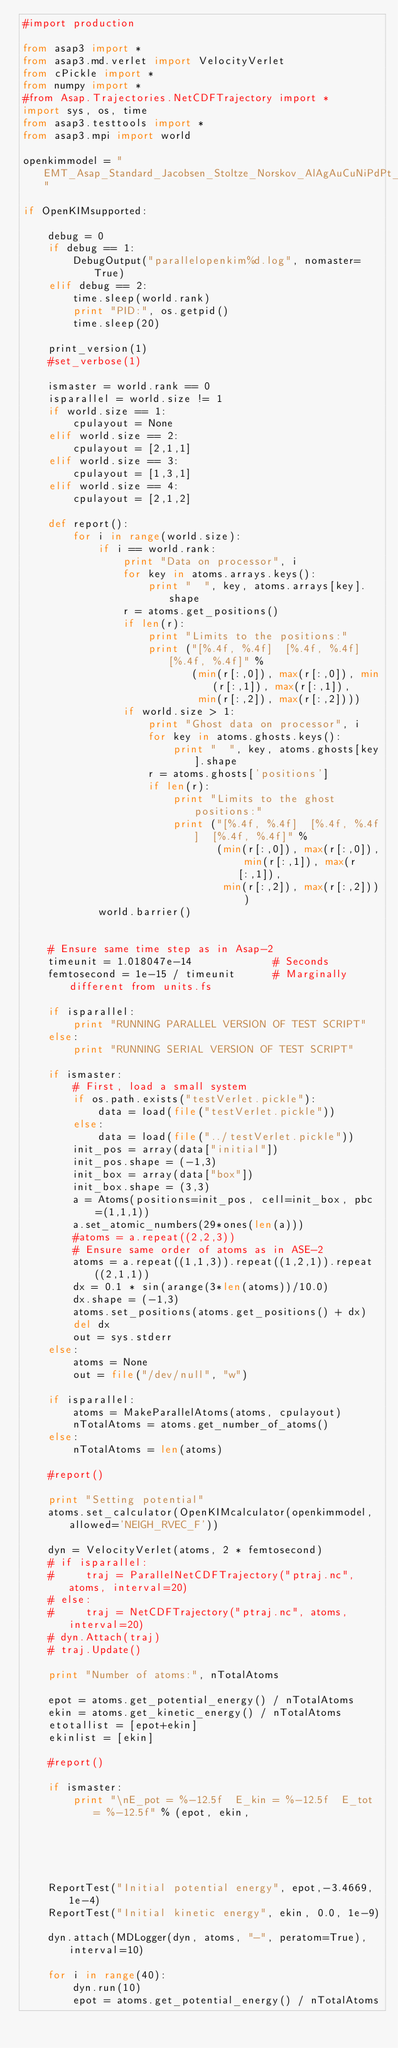<code> <loc_0><loc_0><loc_500><loc_500><_Python_>#import production

from asap3 import *
from asap3.md.verlet import VelocityVerlet
from cPickle import *
from numpy import *
#from Asap.Trajectories.NetCDFTrajectory import *
import sys, os, time
from asap3.testtools import *
from asap3.mpi import world

openkimmodel = "EMT_Asap_Standard_Jacobsen_Stoltze_Norskov_AlAgAuCuNiPdPt__MO_118428466217_002"

if OpenKIMsupported:

    debug = 0
    if debug == 1:
        DebugOutput("parallelopenkim%d.log", nomaster=True)
    elif debug == 2:
        time.sleep(world.rank)
        print "PID:", os.getpid()
        time.sleep(20)

    print_version(1)
    #set_verbose(1)

    ismaster = world.rank == 0
    isparallel = world.size != 1
    if world.size == 1:
        cpulayout = None
    elif world.size == 2:
        cpulayout = [2,1,1]
    elif world.size == 3:
        cpulayout = [1,3,1]
    elif world.size == 4:
        cpulayout = [2,1,2]

    def report():
        for i in range(world.size):
            if i == world.rank:
                print "Data on processor", i
                for key in atoms.arrays.keys():
                    print "  ", key, atoms.arrays[key].shape
                r = atoms.get_positions()
                if len(r):
                    print "Limits to the positions:"
                    print ("[%.4f, %.4f]  [%.4f, %.4f]  [%.4f, %.4f]" %
                           (min(r[:,0]), max(r[:,0]), min(r[:,1]), max(r[:,1]),
                            min(r[:,2]), max(r[:,2])))
                if world.size > 1:
                    print "Ghost data on processor", i
                    for key in atoms.ghosts.keys():
                        print "  ", key, atoms.ghosts[key].shape
                    r = atoms.ghosts['positions']
                    if len(r):
                        print "Limits to the ghost positions:"
                        print ("[%.4f, %.4f]  [%.4f, %.4f]  [%.4f, %.4f]" %
                               (min(r[:,0]), max(r[:,0]), min(r[:,1]), max(r[:,1]),
                                min(r[:,2]), max(r[:,2])))
            world.barrier()


    # Ensure same time step as in Asap-2
    timeunit = 1.018047e-14             # Seconds
    femtosecond = 1e-15 / timeunit      # Marginally different from units.fs

    if isparallel:
        print "RUNNING PARALLEL VERSION OF TEST SCRIPT"
    else:
        print "RUNNING SERIAL VERSION OF TEST SCRIPT"

    if ismaster:
        # First, load a small system
        if os.path.exists("testVerlet.pickle"):
            data = load(file("testVerlet.pickle"))
        else:
            data = load(file("../testVerlet.pickle"))
        init_pos = array(data["initial"])
        init_pos.shape = (-1,3)
        init_box = array(data["box"])
        init_box.shape = (3,3)
        a = Atoms(positions=init_pos, cell=init_box, pbc=(1,1,1))
        a.set_atomic_numbers(29*ones(len(a)))
        #atoms = a.repeat((2,2,3))
        # Ensure same order of atoms as in ASE-2
        atoms = a.repeat((1,1,3)).repeat((1,2,1)).repeat((2,1,1))
        dx = 0.1 * sin(arange(3*len(atoms))/10.0)
        dx.shape = (-1,3)
        atoms.set_positions(atoms.get_positions() + dx)
        del dx
        out = sys.stderr
    else:
        atoms = None
        out = file("/dev/null", "w")

    if isparallel:
        atoms = MakeParallelAtoms(atoms, cpulayout)
        nTotalAtoms = atoms.get_number_of_atoms()
    else:
        nTotalAtoms = len(atoms)

    #report()

    print "Setting potential"
    atoms.set_calculator(OpenKIMcalculator(openkimmodel, allowed='NEIGH_RVEC_F'))

    dyn = VelocityVerlet(atoms, 2 * femtosecond)
    # if isparallel:
    #     traj = ParallelNetCDFTrajectory("ptraj.nc", atoms, interval=20)
    # else:
    #     traj = NetCDFTrajectory("ptraj.nc", atoms, interval=20)
    # dyn.Attach(traj)
    # traj.Update()

    print "Number of atoms:", nTotalAtoms

    epot = atoms.get_potential_energy() / nTotalAtoms
    ekin = atoms.get_kinetic_energy() / nTotalAtoms
    etotallist = [epot+ekin]
    ekinlist = [ekin]

    #report()

    if ismaster:
        print "\nE_pot = %-12.5f  E_kin = %-12.5f  E_tot = %-12.5f" % (epot, ekin,
                                                                     epot+ekin)
    ReportTest("Initial potential energy", epot,-3.4669, 1e-4)
    ReportTest("Initial kinetic energy", ekin, 0.0, 1e-9)

    dyn.attach(MDLogger(dyn, atoms, "-", peratom=True), interval=10)

    for i in range(40):
        dyn.run(10)
        epot = atoms.get_potential_energy() / nTotalAtoms</code> 